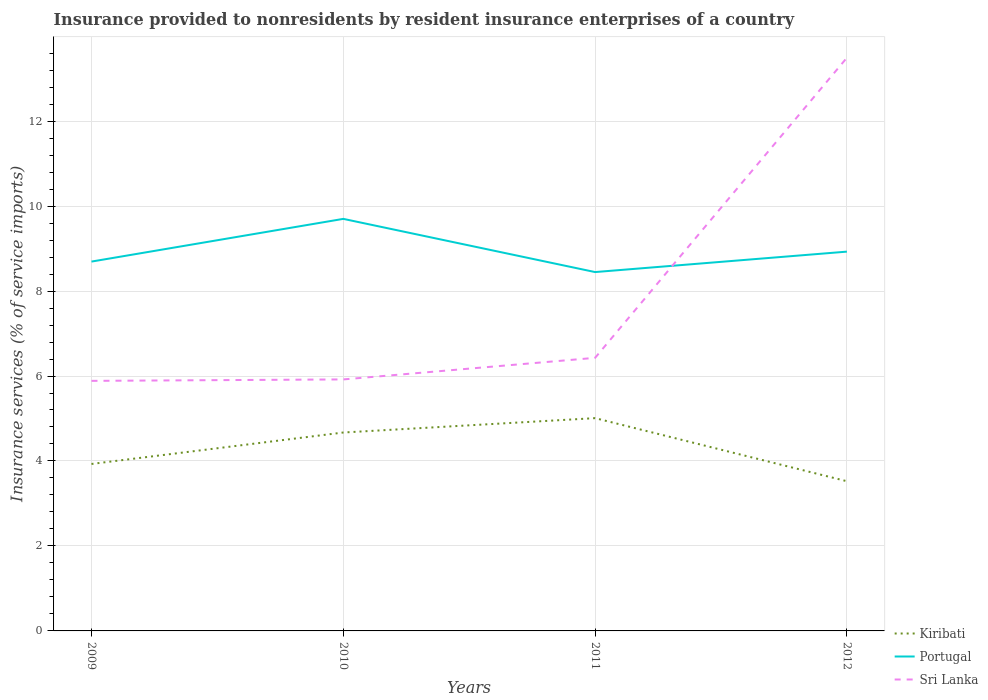How many different coloured lines are there?
Ensure brevity in your answer.  3. Is the number of lines equal to the number of legend labels?
Keep it short and to the point. Yes. Across all years, what is the maximum insurance provided to nonresidents in Sri Lanka?
Your answer should be very brief. 5.89. What is the total insurance provided to nonresidents in Sri Lanka in the graph?
Provide a succinct answer. -0.54. What is the difference between the highest and the second highest insurance provided to nonresidents in Kiribati?
Give a very brief answer. 1.48. How many years are there in the graph?
Offer a terse response. 4. What is the difference between two consecutive major ticks on the Y-axis?
Offer a very short reply. 2. Are the values on the major ticks of Y-axis written in scientific E-notation?
Your response must be concise. No. Does the graph contain any zero values?
Offer a terse response. No. Does the graph contain grids?
Make the answer very short. Yes. Where does the legend appear in the graph?
Keep it short and to the point. Bottom right. How many legend labels are there?
Provide a short and direct response. 3. What is the title of the graph?
Give a very brief answer. Insurance provided to nonresidents by resident insurance enterprises of a country. What is the label or title of the Y-axis?
Your answer should be very brief. Insurance services (% of service imports). What is the Insurance services (% of service imports) in Kiribati in 2009?
Your answer should be compact. 3.93. What is the Insurance services (% of service imports) of Portugal in 2009?
Provide a succinct answer. 8.69. What is the Insurance services (% of service imports) of Sri Lanka in 2009?
Provide a succinct answer. 5.89. What is the Insurance services (% of service imports) of Kiribati in 2010?
Your answer should be very brief. 4.67. What is the Insurance services (% of service imports) of Portugal in 2010?
Provide a succinct answer. 9.7. What is the Insurance services (% of service imports) of Sri Lanka in 2010?
Offer a terse response. 5.92. What is the Insurance services (% of service imports) in Kiribati in 2011?
Your response must be concise. 5.01. What is the Insurance services (% of service imports) in Portugal in 2011?
Your answer should be very brief. 8.45. What is the Insurance services (% of service imports) of Sri Lanka in 2011?
Your answer should be very brief. 6.43. What is the Insurance services (% of service imports) in Kiribati in 2012?
Offer a very short reply. 3.52. What is the Insurance services (% of service imports) of Portugal in 2012?
Ensure brevity in your answer.  8.93. What is the Insurance services (% of service imports) in Sri Lanka in 2012?
Ensure brevity in your answer.  13.49. Across all years, what is the maximum Insurance services (% of service imports) in Kiribati?
Make the answer very short. 5.01. Across all years, what is the maximum Insurance services (% of service imports) of Portugal?
Provide a short and direct response. 9.7. Across all years, what is the maximum Insurance services (% of service imports) in Sri Lanka?
Ensure brevity in your answer.  13.49. Across all years, what is the minimum Insurance services (% of service imports) in Kiribati?
Provide a short and direct response. 3.52. Across all years, what is the minimum Insurance services (% of service imports) of Portugal?
Provide a succinct answer. 8.45. Across all years, what is the minimum Insurance services (% of service imports) of Sri Lanka?
Keep it short and to the point. 5.89. What is the total Insurance services (% of service imports) of Kiribati in the graph?
Provide a succinct answer. 17.13. What is the total Insurance services (% of service imports) in Portugal in the graph?
Your answer should be compact. 35.77. What is the total Insurance services (% of service imports) in Sri Lanka in the graph?
Provide a succinct answer. 31.72. What is the difference between the Insurance services (% of service imports) in Kiribati in 2009 and that in 2010?
Your answer should be compact. -0.74. What is the difference between the Insurance services (% of service imports) in Portugal in 2009 and that in 2010?
Give a very brief answer. -1.01. What is the difference between the Insurance services (% of service imports) of Sri Lanka in 2009 and that in 2010?
Ensure brevity in your answer.  -0.03. What is the difference between the Insurance services (% of service imports) of Kiribati in 2009 and that in 2011?
Your answer should be very brief. -1.08. What is the difference between the Insurance services (% of service imports) of Portugal in 2009 and that in 2011?
Provide a succinct answer. 0.25. What is the difference between the Insurance services (% of service imports) in Sri Lanka in 2009 and that in 2011?
Give a very brief answer. -0.54. What is the difference between the Insurance services (% of service imports) in Kiribati in 2009 and that in 2012?
Make the answer very short. 0.41. What is the difference between the Insurance services (% of service imports) in Portugal in 2009 and that in 2012?
Offer a very short reply. -0.23. What is the difference between the Insurance services (% of service imports) in Sri Lanka in 2009 and that in 2012?
Your answer should be compact. -7.61. What is the difference between the Insurance services (% of service imports) of Kiribati in 2010 and that in 2011?
Ensure brevity in your answer.  -0.34. What is the difference between the Insurance services (% of service imports) of Portugal in 2010 and that in 2011?
Ensure brevity in your answer.  1.25. What is the difference between the Insurance services (% of service imports) in Sri Lanka in 2010 and that in 2011?
Your response must be concise. -0.51. What is the difference between the Insurance services (% of service imports) of Kiribati in 2010 and that in 2012?
Your answer should be compact. 1.15. What is the difference between the Insurance services (% of service imports) in Portugal in 2010 and that in 2012?
Your answer should be very brief. 0.77. What is the difference between the Insurance services (% of service imports) of Sri Lanka in 2010 and that in 2012?
Keep it short and to the point. -7.57. What is the difference between the Insurance services (% of service imports) of Kiribati in 2011 and that in 2012?
Make the answer very short. 1.48. What is the difference between the Insurance services (% of service imports) of Portugal in 2011 and that in 2012?
Offer a very short reply. -0.48. What is the difference between the Insurance services (% of service imports) of Sri Lanka in 2011 and that in 2012?
Give a very brief answer. -7.06. What is the difference between the Insurance services (% of service imports) of Kiribati in 2009 and the Insurance services (% of service imports) of Portugal in 2010?
Ensure brevity in your answer.  -5.77. What is the difference between the Insurance services (% of service imports) in Kiribati in 2009 and the Insurance services (% of service imports) in Sri Lanka in 2010?
Provide a short and direct response. -1.99. What is the difference between the Insurance services (% of service imports) in Portugal in 2009 and the Insurance services (% of service imports) in Sri Lanka in 2010?
Your answer should be compact. 2.77. What is the difference between the Insurance services (% of service imports) of Kiribati in 2009 and the Insurance services (% of service imports) of Portugal in 2011?
Your answer should be compact. -4.52. What is the difference between the Insurance services (% of service imports) of Kiribati in 2009 and the Insurance services (% of service imports) of Sri Lanka in 2011?
Make the answer very short. -2.5. What is the difference between the Insurance services (% of service imports) of Portugal in 2009 and the Insurance services (% of service imports) of Sri Lanka in 2011?
Offer a very short reply. 2.27. What is the difference between the Insurance services (% of service imports) in Kiribati in 2009 and the Insurance services (% of service imports) in Portugal in 2012?
Offer a terse response. -5. What is the difference between the Insurance services (% of service imports) in Kiribati in 2009 and the Insurance services (% of service imports) in Sri Lanka in 2012?
Your answer should be compact. -9.56. What is the difference between the Insurance services (% of service imports) of Portugal in 2009 and the Insurance services (% of service imports) of Sri Lanka in 2012?
Provide a succinct answer. -4.8. What is the difference between the Insurance services (% of service imports) of Kiribati in 2010 and the Insurance services (% of service imports) of Portugal in 2011?
Keep it short and to the point. -3.78. What is the difference between the Insurance services (% of service imports) in Kiribati in 2010 and the Insurance services (% of service imports) in Sri Lanka in 2011?
Provide a succinct answer. -1.76. What is the difference between the Insurance services (% of service imports) in Portugal in 2010 and the Insurance services (% of service imports) in Sri Lanka in 2011?
Give a very brief answer. 3.27. What is the difference between the Insurance services (% of service imports) of Kiribati in 2010 and the Insurance services (% of service imports) of Portugal in 2012?
Provide a succinct answer. -4.26. What is the difference between the Insurance services (% of service imports) of Kiribati in 2010 and the Insurance services (% of service imports) of Sri Lanka in 2012?
Ensure brevity in your answer.  -8.82. What is the difference between the Insurance services (% of service imports) of Portugal in 2010 and the Insurance services (% of service imports) of Sri Lanka in 2012?
Your answer should be compact. -3.79. What is the difference between the Insurance services (% of service imports) in Kiribati in 2011 and the Insurance services (% of service imports) in Portugal in 2012?
Your response must be concise. -3.92. What is the difference between the Insurance services (% of service imports) of Kiribati in 2011 and the Insurance services (% of service imports) of Sri Lanka in 2012?
Give a very brief answer. -8.48. What is the difference between the Insurance services (% of service imports) of Portugal in 2011 and the Insurance services (% of service imports) of Sri Lanka in 2012?
Your answer should be very brief. -5.04. What is the average Insurance services (% of service imports) in Kiribati per year?
Ensure brevity in your answer.  4.28. What is the average Insurance services (% of service imports) in Portugal per year?
Keep it short and to the point. 8.94. What is the average Insurance services (% of service imports) of Sri Lanka per year?
Make the answer very short. 7.93. In the year 2009, what is the difference between the Insurance services (% of service imports) in Kiribati and Insurance services (% of service imports) in Portugal?
Your answer should be compact. -4.76. In the year 2009, what is the difference between the Insurance services (% of service imports) of Kiribati and Insurance services (% of service imports) of Sri Lanka?
Make the answer very short. -1.96. In the year 2009, what is the difference between the Insurance services (% of service imports) of Portugal and Insurance services (% of service imports) of Sri Lanka?
Offer a very short reply. 2.81. In the year 2010, what is the difference between the Insurance services (% of service imports) of Kiribati and Insurance services (% of service imports) of Portugal?
Your answer should be compact. -5.03. In the year 2010, what is the difference between the Insurance services (% of service imports) of Kiribati and Insurance services (% of service imports) of Sri Lanka?
Your answer should be very brief. -1.25. In the year 2010, what is the difference between the Insurance services (% of service imports) of Portugal and Insurance services (% of service imports) of Sri Lanka?
Provide a succinct answer. 3.78. In the year 2011, what is the difference between the Insurance services (% of service imports) in Kiribati and Insurance services (% of service imports) in Portugal?
Provide a short and direct response. -3.44. In the year 2011, what is the difference between the Insurance services (% of service imports) in Kiribati and Insurance services (% of service imports) in Sri Lanka?
Your answer should be compact. -1.42. In the year 2011, what is the difference between the Insurance services (% of service imports) in Portugal and Insurance services (% of service imports) in Sri Lanka?
Offer a very short reply. 2.02. In the year 2012, what is the difference between the Insurance services (% of service imports) of Kiribati and Insurance services (% of service imports) of Portugal?
Offer a terse response. -5.4. In the year 2012, what is the difference between the Insurance services (% of service imports) in Kiribati and Insurance services (% of service imports) in Sri Lanka?
Provide a short and direct response. -9.97. In the year 2012, what is the difference between the Insurance services (% of service imports) in Portugal and Insurance services (% of service imports) in Sri Lanka?
Keep it short and to the point. -4.56. What is the ratio of the Insurance services (% of service imports) of Kiribati in 2009 to that in 2010?
Provide a succinct answer. 0.84. What is the ratio of the Insurance services (% of service imports) in Portugal in 2009 to that in 2010?
Provide a succinct answer. 0.9. What is the ratio of the Insurance services (% of service imports) in Kiribati in 2009 to that in 2011?
Provide a succinct answer. 0.78. What is the ratio of the Insurance services (% of service imports) of Portugal in 2009 to that in 2011?
Provide a succinct answer. 1.03. What is the ratio of the Insurance services (% of service imports) of Sri Lanka in 2009 to that in 2011?
Provide a short and direct response. 0.92. What is the ratio of the Insurance services (% of service imports) in Kiribati in 2009 to that in 2012?
Ensure brevity in your answer.  1.12. What is the ratio of the Insurance services (% of service imports) of Portugal in 2009 to that in 2012?
Provide a short and direct response. 0.97. What is the ratio of the Insurance services (% of service imports) in Sri Lanka in 2009 to that in 2012?
Keep it short and to the point. 0.44. What is the ratio of the Insurance services (% of service imports) in Kiribati in 2010 to that in 2011?
Offer a terse response. 0.93. What is the ratio of the Insurance services (% of service imports) of Portugal in 2010 to that in 2011?
Ensure brevity in your answer.  1.15. What is the ratio of the Insurance services (% of service imports) of Sri Lanka in 2010 to that in 2011?
Your response must be concise. 0.92. What is the ratio of the Insurance services (% of service imports) of Kiribati in 2010 to that in 2012?
Your answer should be compact. 1.33. What is the ratio of the Insurance services (% of service imports) of Portugal in 2010 to that in 2012?
Provide a short and direct response. 1.09. What is the ratio of the Insurance services (% of service imports) in Sri Lanka in 2010 to that in 2012?
Make the answer very short. 0.44. What is the ratio of the Insurance services (% of service imports) of Kiribati in 2011 to that in 2012?
Provide a succinct answer. 1.42. What is the ratio of the Insurance services (% of service imports) of Portugal in 2011 to that in 2012?
Your answer should be very brief. 0.95. What is the ratio of the Insurance services (% of service imports) in Sri Lanka in 2011 to that in 2012?
Give a very brief answer. 0.48. What is the difference between the highest and the second highest Insurance services (% of service imports) of Kiribati?
Offer a terse response. 0.34. What is the difference between the highest and the second highest Insurance services (% of service imports) of Portugal?
Offer a very short reply. 0.77. What is the difference between the highest and the second highest Insurance services (% of service imports) in Sri Lanka?
Your answer should be very brief. 7.06. What is the difference between the highest and the lowest Insurance services (% of service imports) in Kiribati?
Make the answer very short. 1.48. What is the difference between the highest and the lowest Insurance services (% of service imports) of Portugal?
Offer a very short reply. 1.25. What is the difference between the highest and the lowest Insurance services (% of service imports) of Sri Lanka?
Offer a terse response. 7.61. 